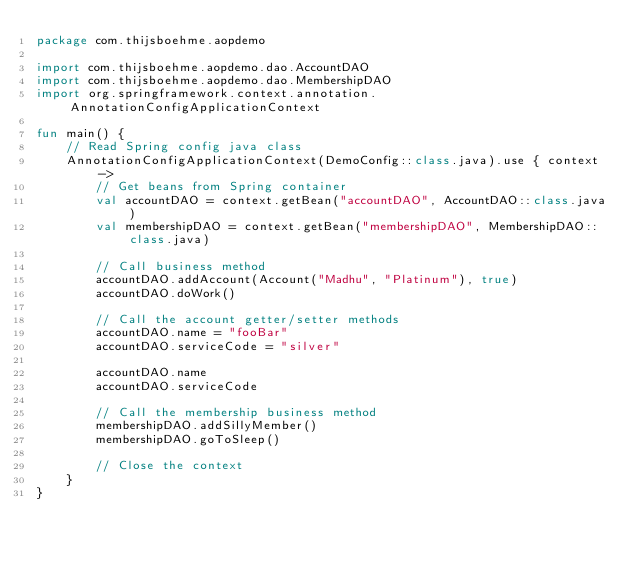<code> <loc_0><loc_0><loc_500><loc_500><_Kotlin_>package com.thijsboehme.aopdemo

import com.thijsboehme.aopdemo.dao.AccountDAO
import com.thijsboehme.aopdemo.dao.MembershipDAO
import org.springframework.context.annotation.AnnotationConfigApplicationContext

fun main() {
    // Read Spring config java class
    AnnotationConfigApplicationContext(DemoConfig::class.java).use { context ->
        // Get beans from Spring container
        val accountDAO = context.getBean("accountDAO", AccountDAO::class.java)
        val membershipDAO = context.getBean("membershipDAO", MembershipDAO::class.java)

        // Call business method
        accountDAO.addAccount(Account("Madhu", "Platinum"), true)
        accountDAO.doWork()

        // Call the account getter/setter methods
        accountDAO.name = "fooBar"
        accountDAO.serviceCode = "silver"

        accountDAO.name
        accountDAO.serviceCode

        // Call the membership business method
        membershipDAO.addSillyMember()
        membershipDAO.goToSleep()

        // Close the context
    }
}
</code> 